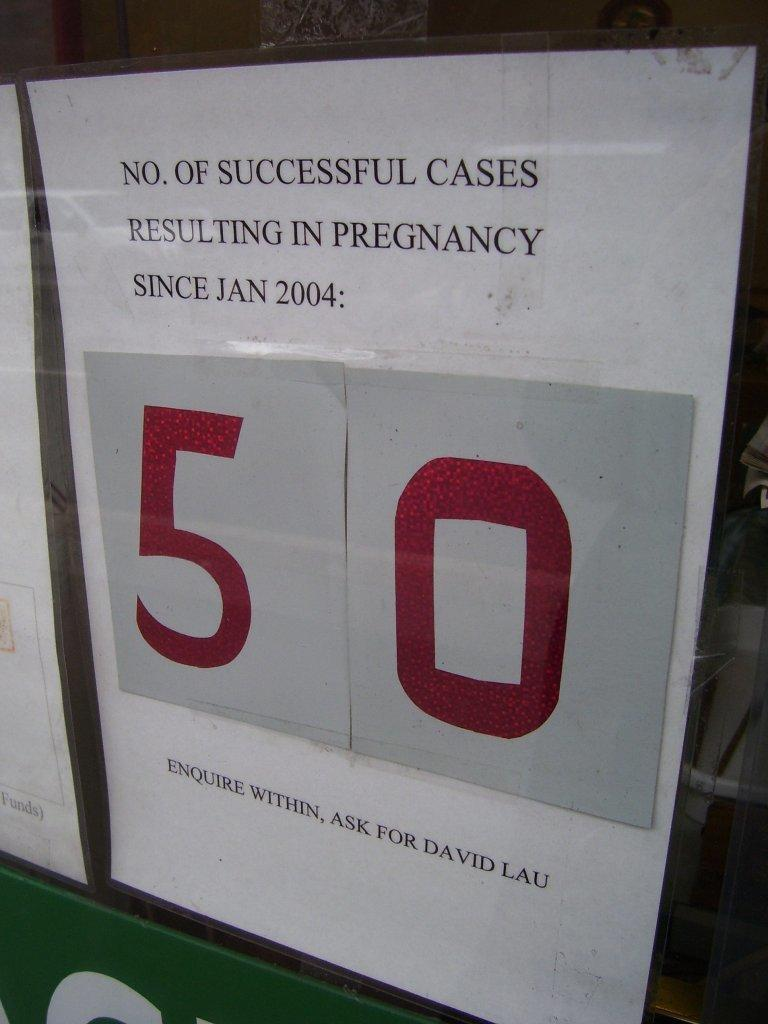<image>
Render a clear and concise summary of the photo. Paper on a wall that has the number 50 on it. 